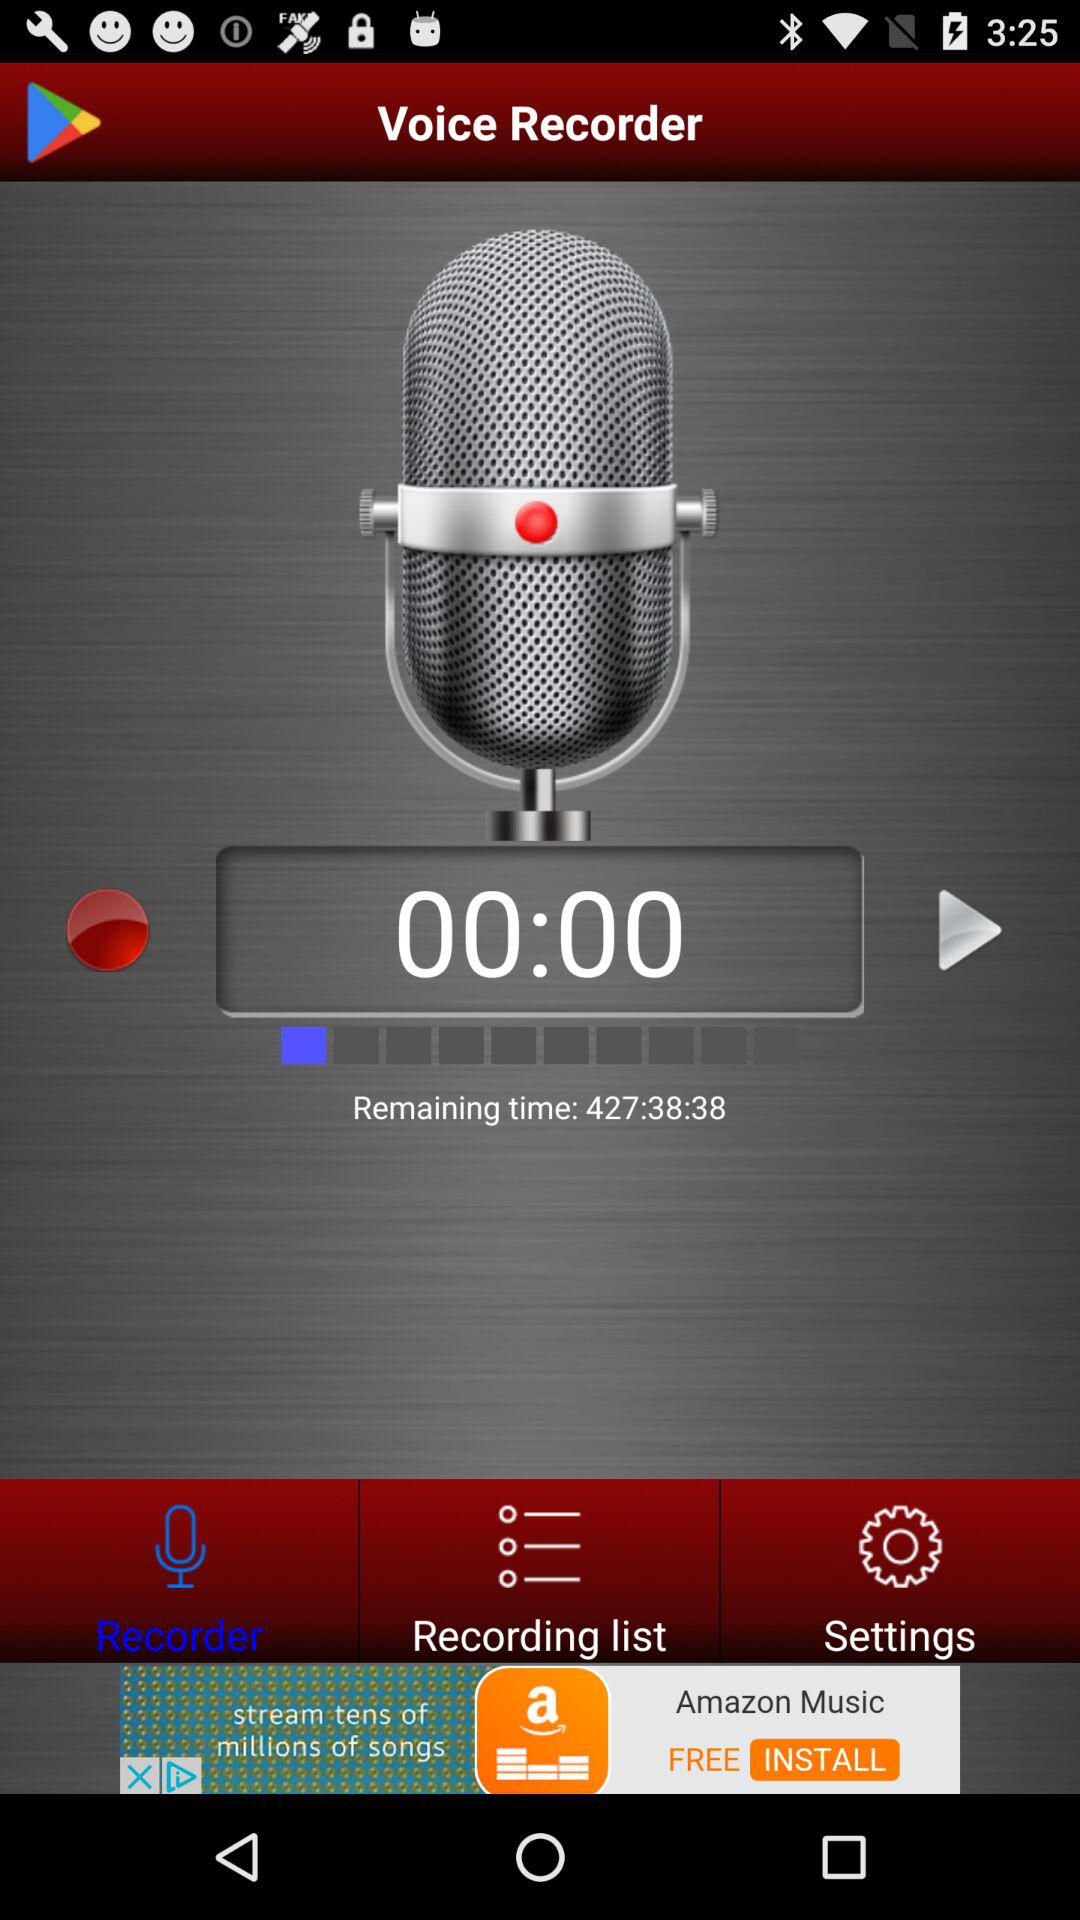What is the name of the application? The name of the application is "Voice Recorder". 